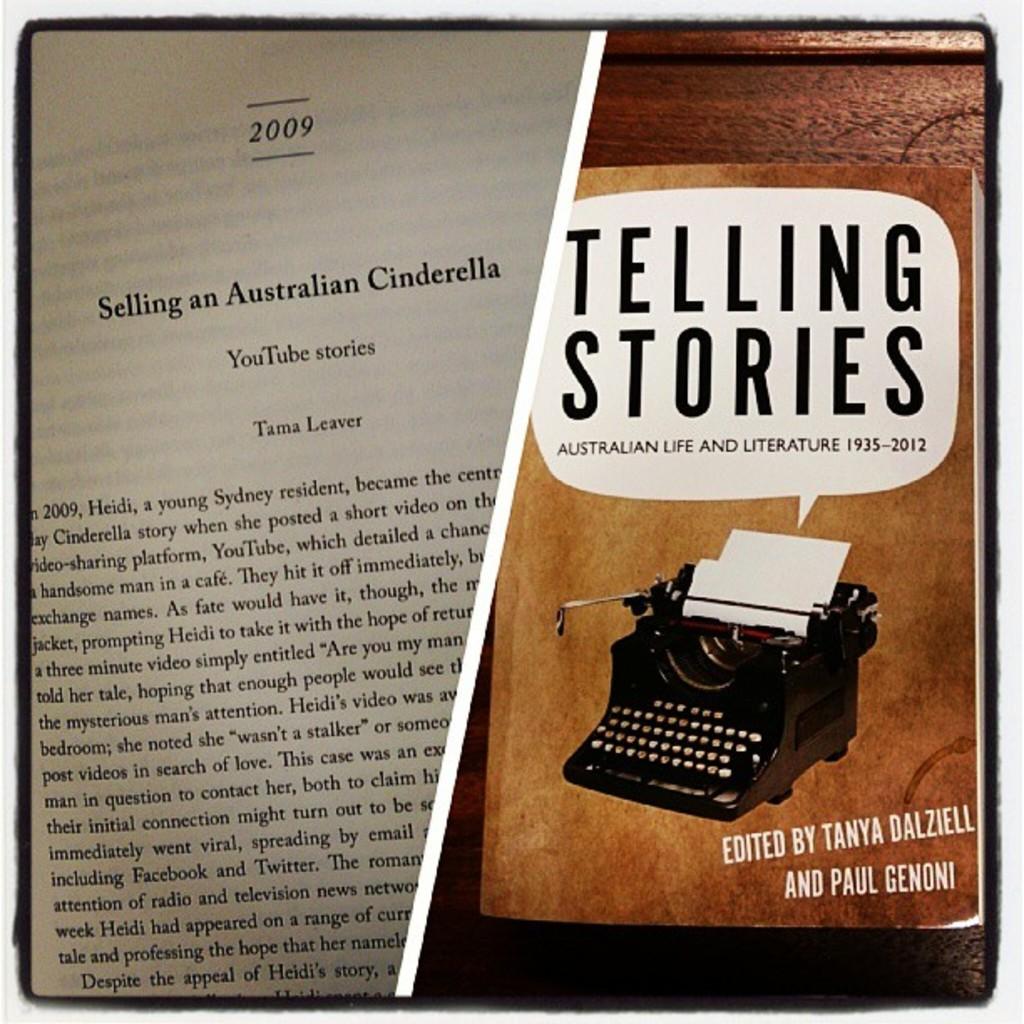What year is selling an australian cinderella from?
Provide a succinct answer. 2009. 